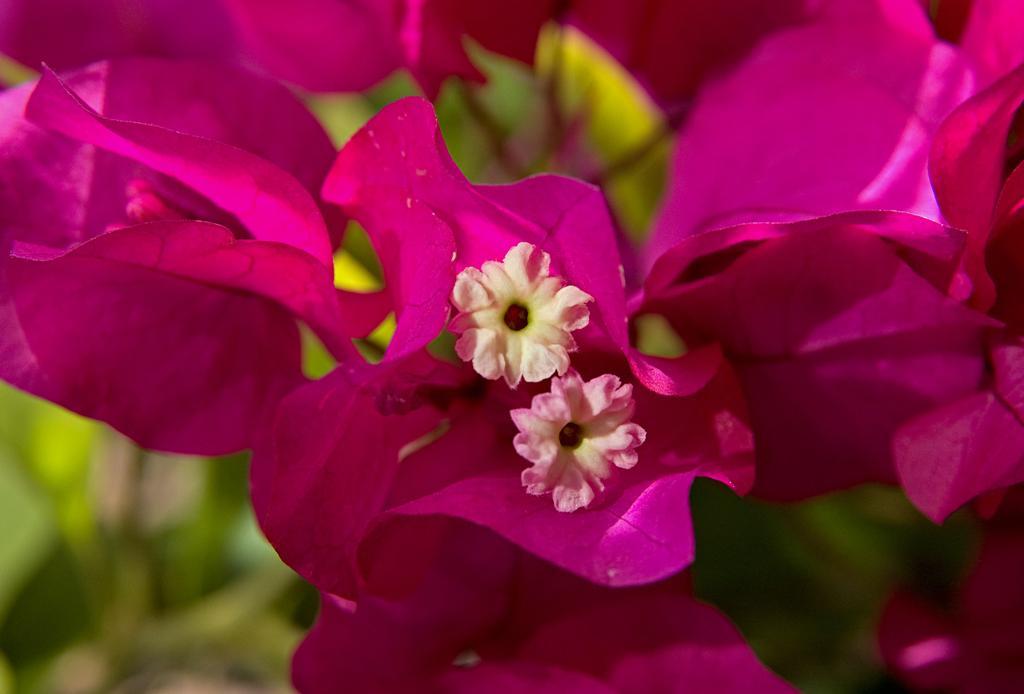In one or two sentences, can you explain what this image depicts? In the center of the image, we can see flowers, which are in pink color. 